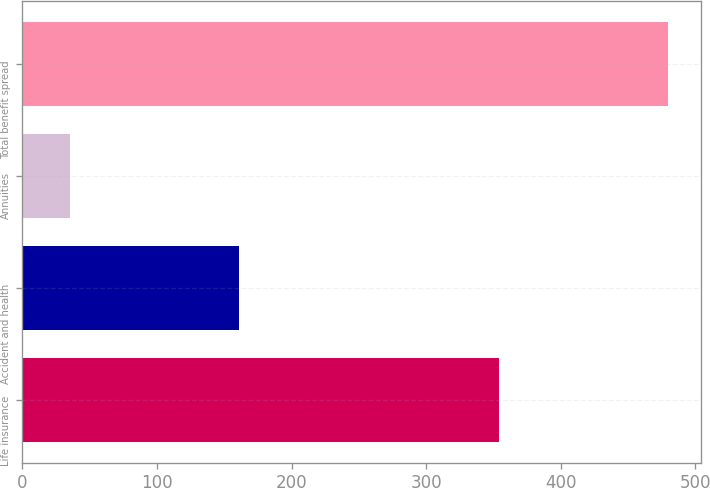Convert chart to OTSL. <chart><loc_0><loc_0><loc_500><loc_500><bar_chart><fcel>Life insurance<fcel>Accident and health<fcel>Annuities<fcel>Total benefit spread<nl><fcel>354<fcel>161<fcel>35<fcel>480<nl></chart> 